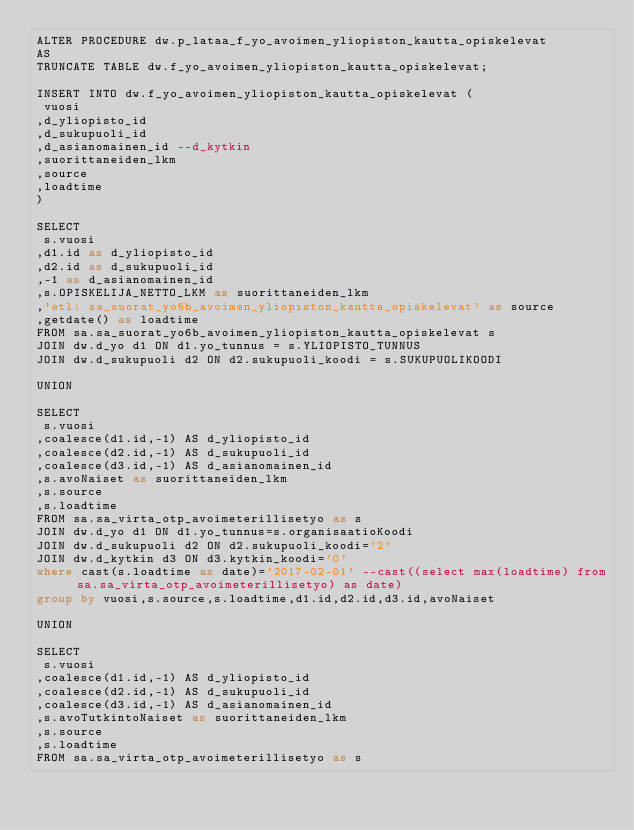Convert code to text. <code><loc_0><loc_0><loc_500><loc_500><_SQL_>ALTER PROCEDURE dw.p_lataa_f_yo_avoimen_yliopiston_kautta_opiskelevat
AS
TRUNCATE TABLE dw.f_yo_avoimen_yliopiston_kautta_opiskelevat;

INSERT INTO dw.f_yo_avoimen_yliopiston_kautta_opiskelevat (
 vuosi
,d_yliopisto_id
,d_sukupuoli_id
,d_asianomainen_id --d_kytkin
,suorittaneiden_lkm 
,source
,loadtime
)

SELECT
 s.vuosi
,d1.id as d_yliopisto_id
,d2.id as d_sukupuoli_id
,-1 as d_asianomainen_id
,s.OPISKELIJA_NETTO_LKM as suorittaneiden_lkm
,'etl: sa_suorat_yo6b_avoimen_yliopiston_kautta_opiskelevat' as source
,getdate() as loadtime
FROM sa.sa_suorat_yo6b_avoimen_yliopiston_kautta_opiskelevat s
JOIN dw.d_yo d1 ON d1.yo_tunnus = s.YLIOPISTO_TUNNUS
JOIN dw.d_sukupuoli d2 ON d2.sukupuoli_koodi = s.SUKUPUOLIKOODI

UNION

SELECT 
 s.vuosi
,coalesce(d1.id,-1) AS d_yliopisto_id
,coalesce(d2.id,-1) AS d_sukupuoli_id
,coalesce(d3.id,-1) AS d_asianomainen_id
,s.avoNaiset as suorittaneiden_lkm
,s.source
,s.loadtime
FROM sa.sa_virta_otp_avoimeterillisetyo as s
JOIN dw.d_yo d1 ON d1.yo_tunnus=s.organisaatioKoodi
JOIN dw.d_sukupuoli d2 ON d2.sukupuoli_koodi='2'
JOIN dw.d_kytkin d3 ON d3.kytkin_koodi='0'
where cast(s.loadtime as date)='2017-02-01' --cast((select max(loadtime) from sa.sa_virta_otp_avoimeterillisetyo) as date)
group by vuosi,s.source,s.loadtime,d1.id,d2.id,d3.id,avoNaiset

UNION

SELECT 
 s.vuosi
,coalesce(d1.id,-1) AS d_yliopisto_id
,coalesce(d2.id,-1) AS d_sukupuoli_id
,coalesce(d3.id,-1) AS d_asianomainen_id
,s.avoTutkintoNaiset as suorittaneiden_lkm
,s.source
,s.loadtime
FROM sa.sa_virta_otp_avoimeterillisetyo as s</code> 